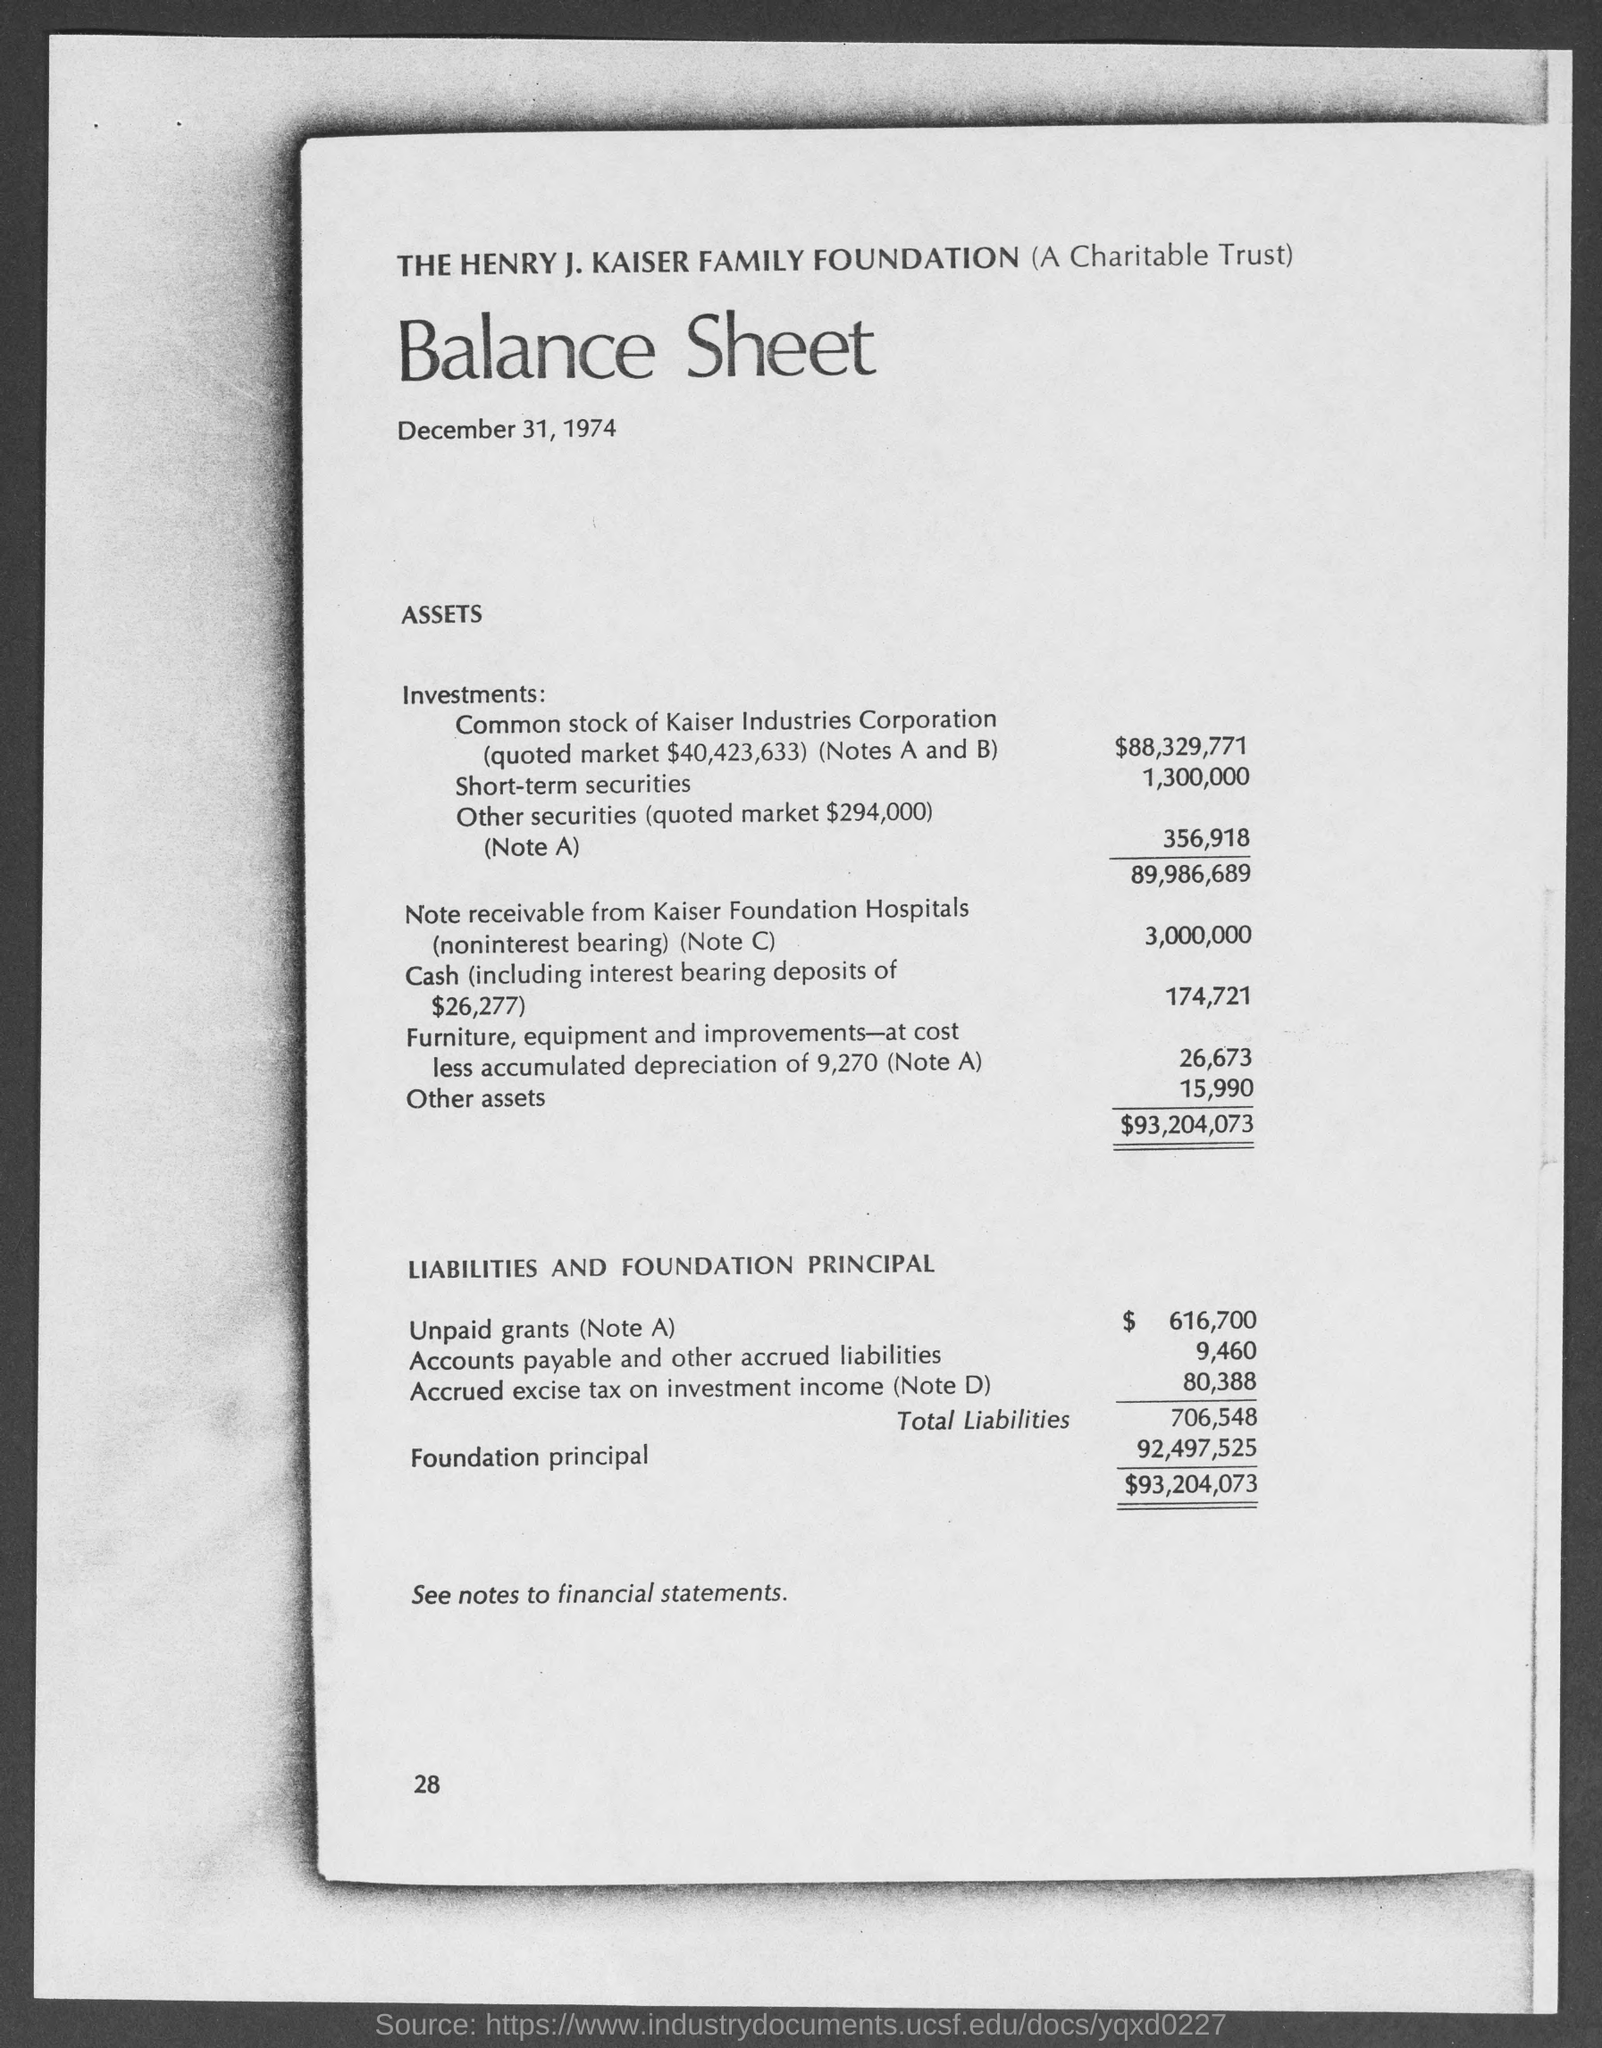Give some essential details in this illustration. The amount of accrued excise tax on investment income, as noted in Note D, is 80,388. As of the current date, the amount of unpaid grants (refer to Note A) is approximately $616,700. The name of the foundation is the Henry J. Kaiser Family Foundation. The amount of other securities is 356,918. The foundation principal amount is $92,497,525. 